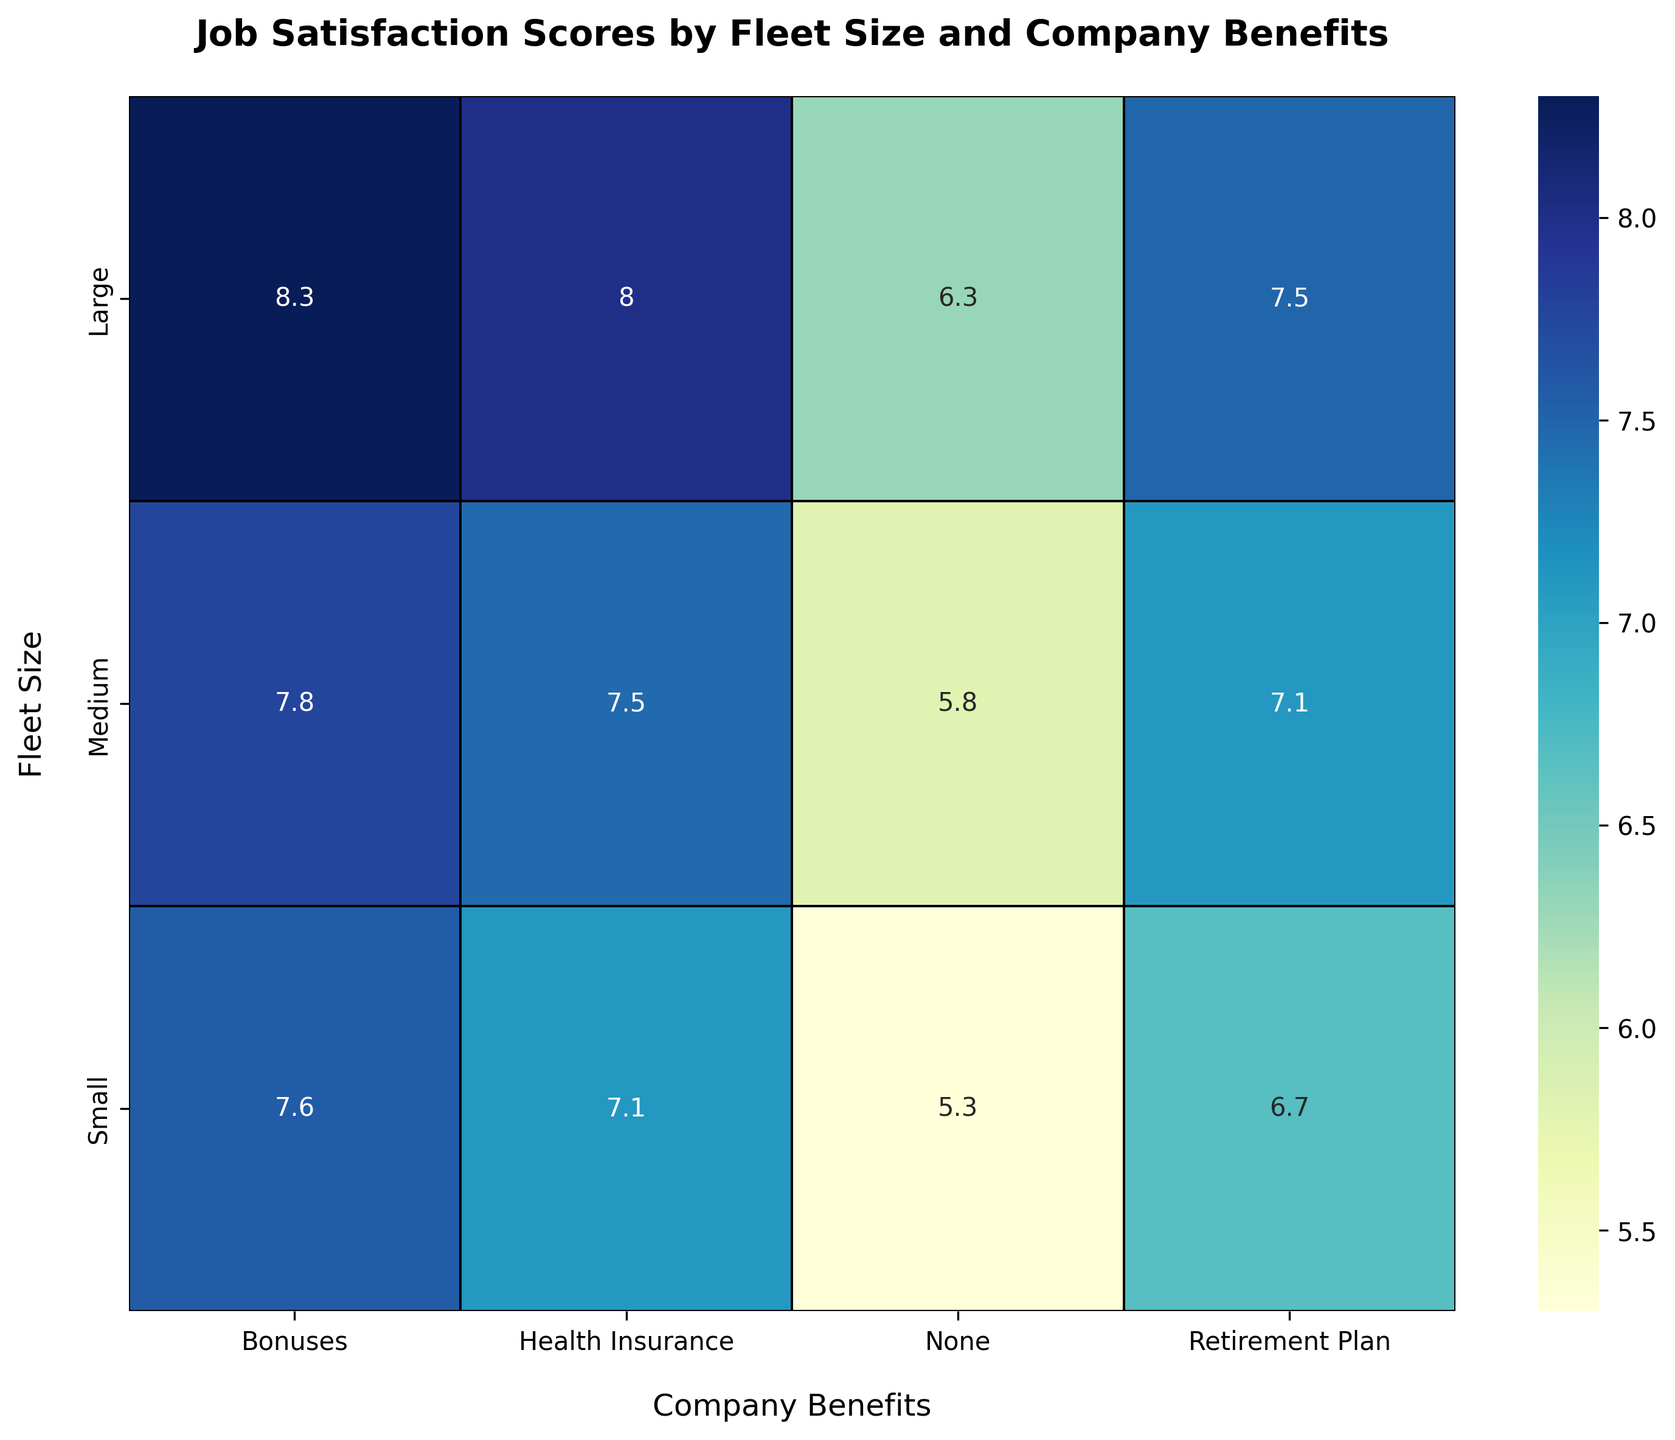What's the average job satisfaction score for small fleet size with health insurance? First, identify the job satisfaction scores for small fleet size with health insurance, which are 7.2, 7.0, and 7.1. Sum these values (7.2 + 7.0 + 7.1 = 21.3) and divide by the number of values (21.3 / 3) to find the average.
Answer: 7.1 Does large fleet size with bonuses result in a higher job satisfaction score compared to medium fleet size with bonuses? Compare the job satisfaction scores for large fleet size with bonuses (8.3, 8.2, 8.4) to those for medium fleet size with bonuses (7.8, 7.6, 7.9). The averages are 8.3 and 7.77 respectively. Since 8.3 is greater than 7.77, the answer is yes.
Answer: Yes Which fleet size and benefits combination has the lowest job satisfaction score? Scan the heatmap for the lowest value across all combinations. The value 5.2 (small fleet size with no benefits) is the lowest.
Answer: Small fleet size with no benefits What is the difference between the job satisfaction score for a large fleet size with health insurance and a medium fleet size with no benefits? Locate the values for large fleet size with health insurance (averaging to 8.0) and medium fleet size with no benefits (averaging to 5.8). Subtract the latter from the former (8.0 - 5.8).
Answer: 2.2 Is the job satisfaction score higher for small fleet size with retirement plans or health insurance? Compare the job satisfaction scores for small fleet size with retirement plans (6.8, 6.5, 6.7) to those with health insurance (7.2, 7.0, 7.1). Their averages are 6.67 and 7.1 respectively. Since 7.1 is higher, the answer is health insurance.
Answer: Health insurance How does the color intensity vary between small fleet size with bonuses and large fleet size with health insurance? The color intensity is higher (darker shade) for large fleet size with health insurance compared to small fleet size with bonuses, indicating higher job satisfaction scores.
Answer: Large fleet size with health insurance is darker What is the average difference in job satisfaction scores between fleets with and without health insurance across all sizes? Calculate the average job satisfaction scores for fleets with health insurance (7.73) and without health insurance (5.7) across all sizes. Subtract one from the other (7.73 - 5.7).
Answer: 2.03 